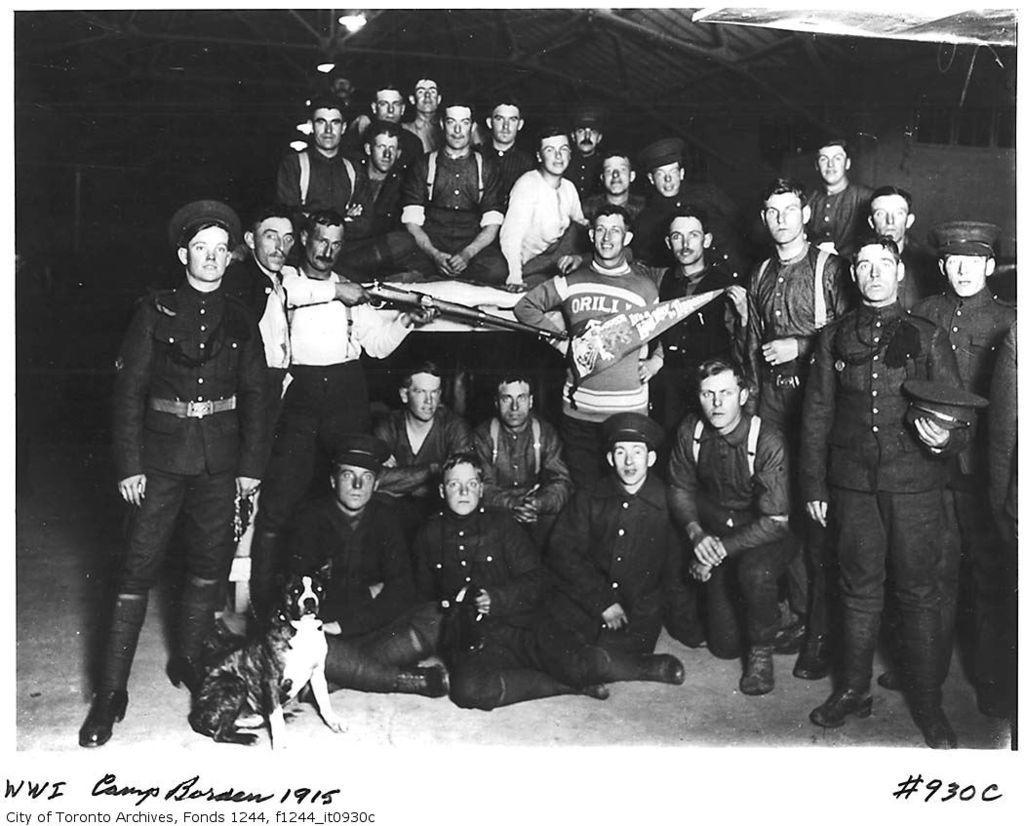Describe this image in one or two sentences. This is a black and white image. In the center of the image there are people. There is a dog. In the background of the image there is a shed. 